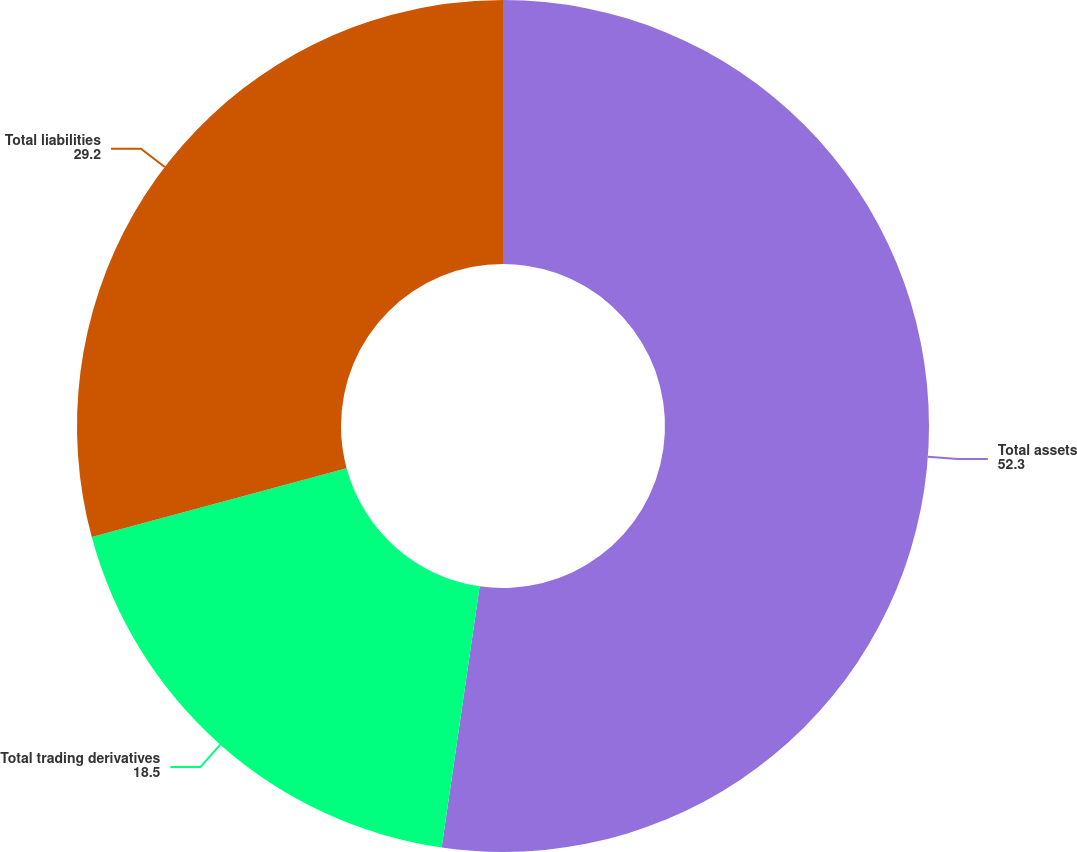Convert chart to OTSL. <chart><loc_0><loc_0><loc_500><loc_500><pie_chart><fcel>Total assets<fcel>Total trading derivatives<fcel>Total liabilities<nl><fcel>52.3%<fcel>18.5%<fcel>29.2%<nl></chart> 